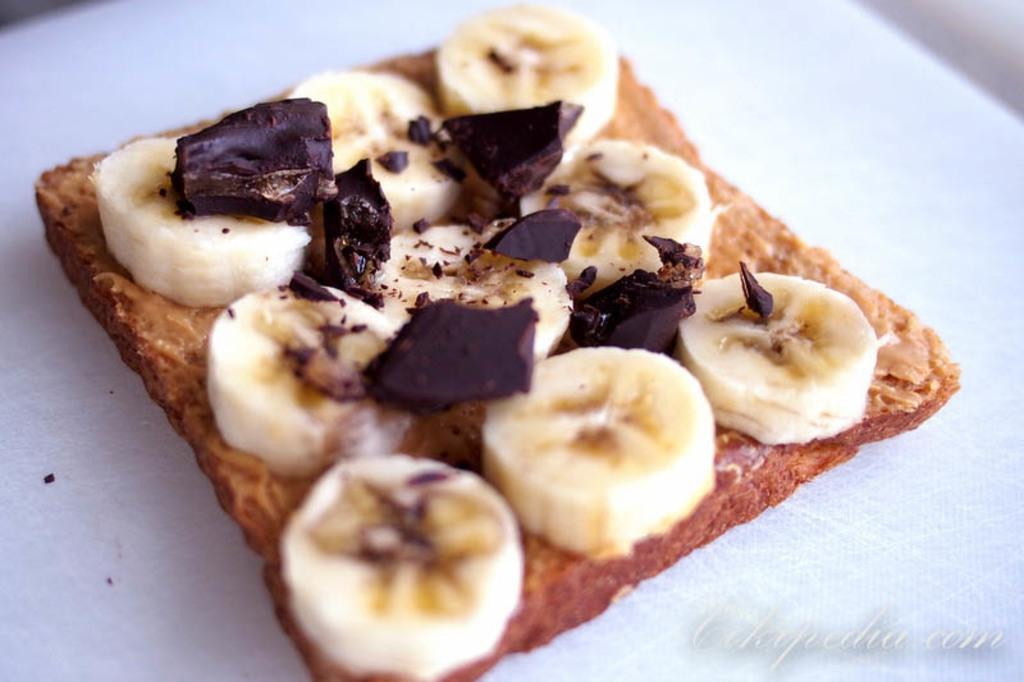What type of fruit can be seen in the image? There are banana slices in the image. What other food items are present in the image? There are other food items in the image, but their specific types are not mentioned in the facts. What color is the object containing the food items? The object containing the food items appears to be white. Is there any additional information about the image itself? Yes, there is a watermark on the image. Can you see a wren perched on the edge of the banana slices in the image? No, there is no wren present in the image. What type of mark is visible on the arm of the person holding the food items? There is no person holding the food items in the image, and therefore no arm or mark to be seen. 